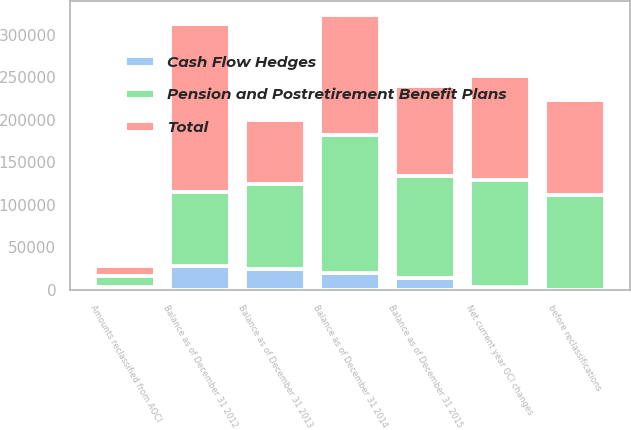<chart> <loc_0><loc_0><loc_500><loc_500><stacked_bar_chart><ecel><fcel>Balance as of December 31 2012<fcel>before reclassifications<fcel>Amounts reclassified from AOCI<fcel>Net current year OCI changes<fcel>Balance as of December 31 2013<fcel>Balance as of December 31 2014<fcel>Balance as of December 31 2015<nl><fcel>Cash Flow Hedges<fcel>28170<fcel>0<fcel>2992<fcel>2992<fcel>25178<fcel>20322<fcel>14494<nl><fcel>Total<fcel>197347<fcel>111883<fcel>11011<fcel>122894<fcel>74453<fcel>141392<fcel>105575<nl><fcel>Pension and Postretirement Benefit Plans<fcel>87042<fcel>111883<fcel>14003<fcel>125886<fcel>99631<fcel>161714<fcel>120069<nl></chart> 